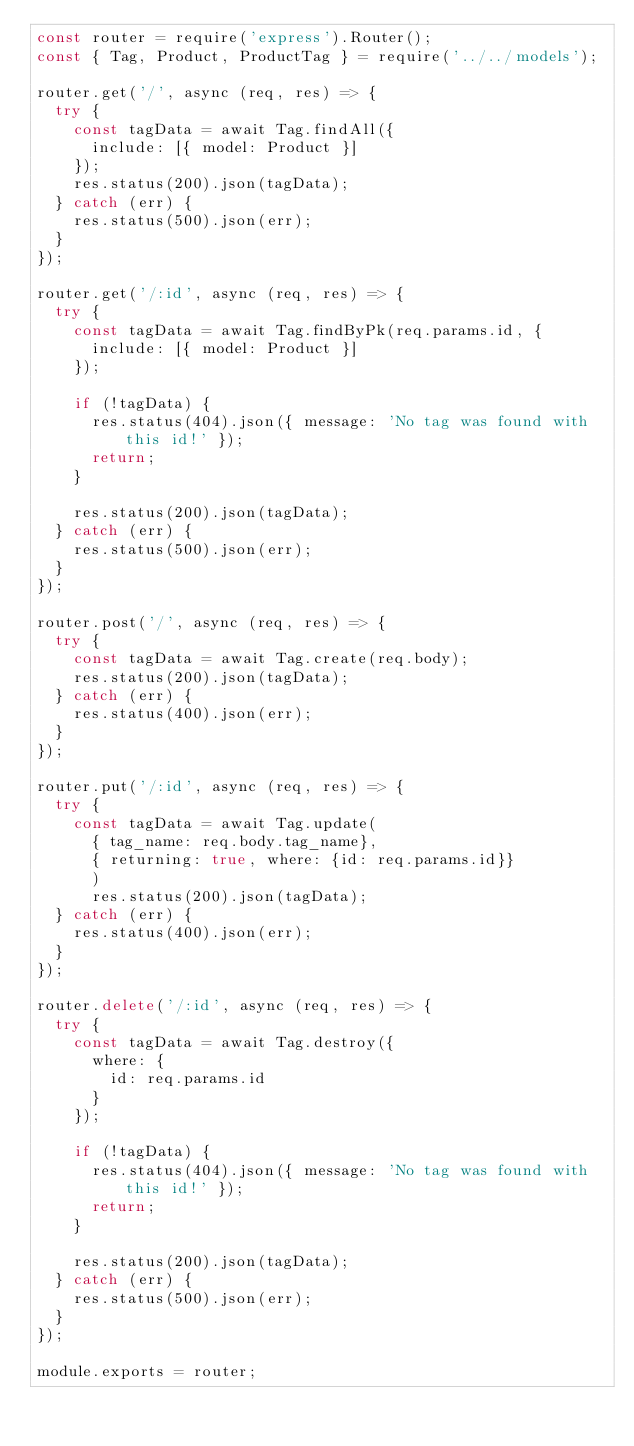<code> <loc_0><loc_0><loc_500><loc_500><_JavaScript_>const router = require('express').Router();
const { Tag, Product, ProductTag } = require('../../models');

router.get('/', async (req, res) => {
  try {
    const tagData = await Tag.findAll({
      include: [{ model: Product }]
    });
    res.status(200).json(tagData);
  } catch (err) {
    res.status(500).json(err);
  }
});

router.get('/:id', async (req, res) => {
  try {
    const tagData = await Tag.findByPk(req.params.id, {
      include: [{ model: Product }]
    });

    if (!tagData) {
      res.status(404).json({ message: 'No tag was found with this id!' });
      return;
    }

    res.status(200).json(tagData);
  } catch (err) {
    res.status(500).json(err);
  }
});

router.post('/', async (req, res) => {
  try {
    const tagData = await Tag.create(req.body);
    res.status(200).json(tagData);
  } catch (err) {
    res.status(400).json(err);
  }
});

router.put('/:id', async (req, res) => {
  try {
    const tagData = await Tag.update(
      { tag_name: req.body.tag_name},
      { returning: true, where: {id: req.params.id}}
      )
      res.status(200).json(tagData);
  } catch (err) {
    res.status(400).json(err);
  }
});

router.delete('/:id', async (req, res) => {
  try {
    const tagData = await Tag.destroy({
      where: {
        id: req.params.id
      }
    });

    if (!tagData) {
      res.status(404).json({ message: 'No tag was found with this id!' });
      return;
    }

    res.status(200).json(tagData);
  } catch (err) {
    res.status(500).json(err);
  }
});

module.exports = router;</code> 